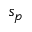Convert formula to latex. <formula><loc_0><loc_0><loc_500><loc_500>s _ { p }</formula> 